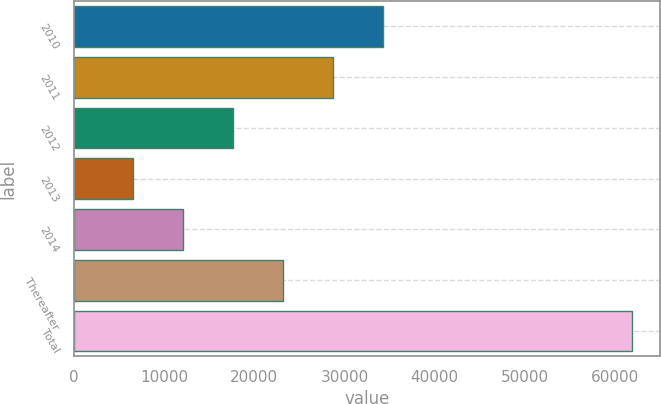Convert chart to OTSL. <chart><loc_0><loc_0><loc_500><loc_500><bar_chart><fcel>2010<fcel>2011<fcel>2012<fcel>2013<fcel>2014<fcel>Thereafter<fcel>Total<nl><fcel>34228<fcel>28696.6<fcel>17633.8<fcel>6571<fcel>12102.4<fcel>23165.2<fcel>61885<nl></chart> 